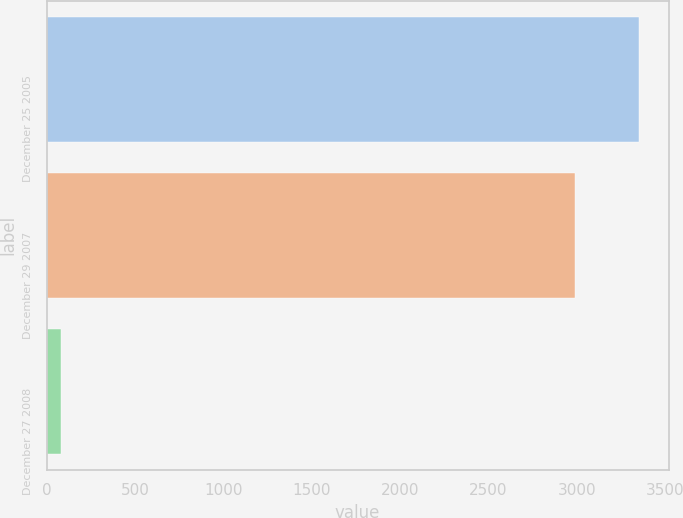<chart> <loc_0><loc_0><loc_500><loc_500><bar_chart><fcel>December 25 2005<fcel>December 29 2007<fcel>December 27 2008<nl><fcel>3352<fcel>2990<fcel>82<nl></chart> 